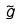Convert formula to latex. <formula><loc_0><loc_0><loc_500><loc_500>\tilde { g }</formula> 